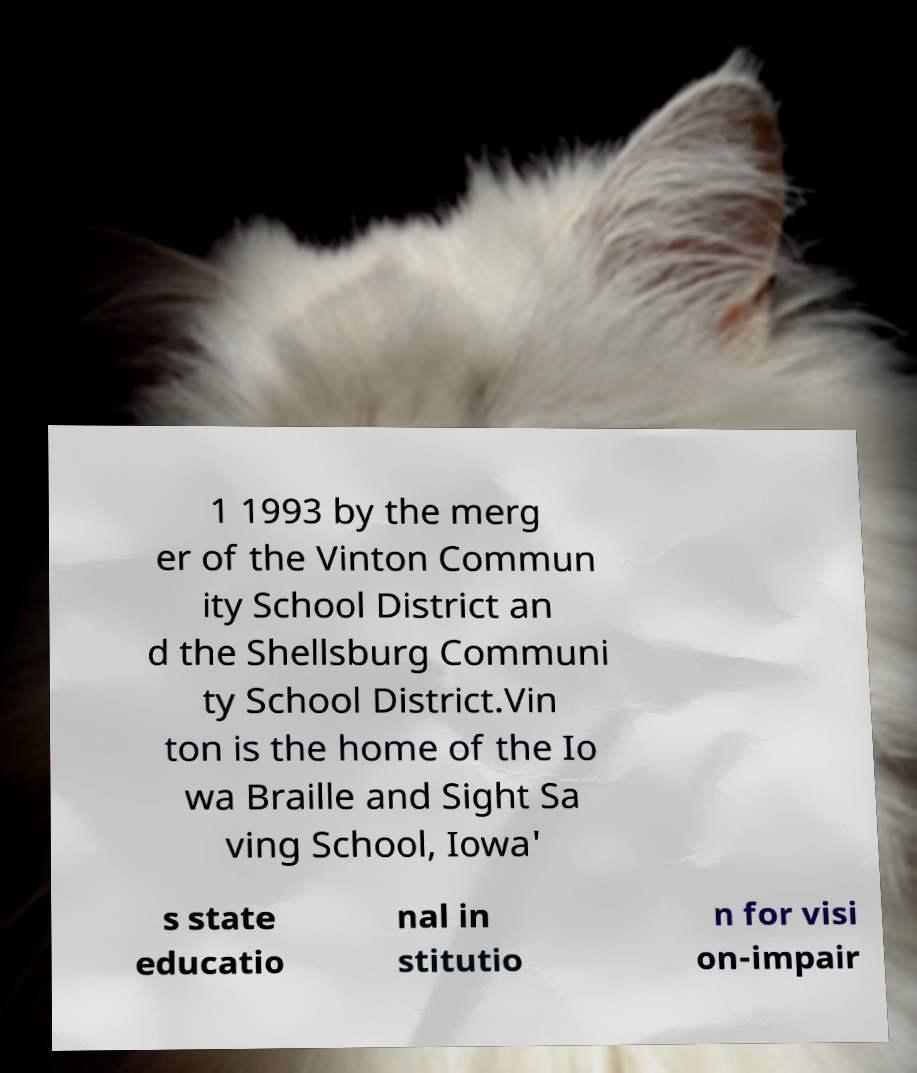Could you extract and type out the text from this image? 1 1993 by the merg er of the Vinton Commun ity School District an d the Shellsburg Communi ty School District.Vin ton is the home of the Io wa Braille and Sight Sa ving School, Iowa' s state educatio nal in stitutio n for visi on-impair 